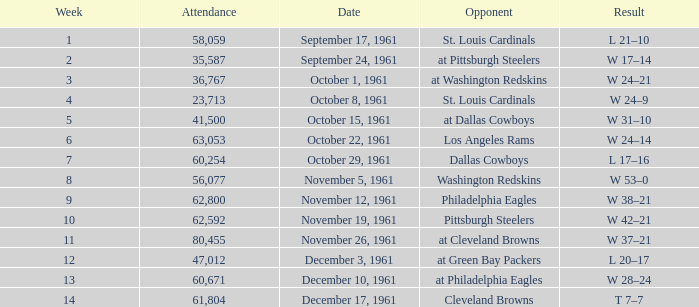Which Attendance has a Date of november 19, 1961? 62592.0. 